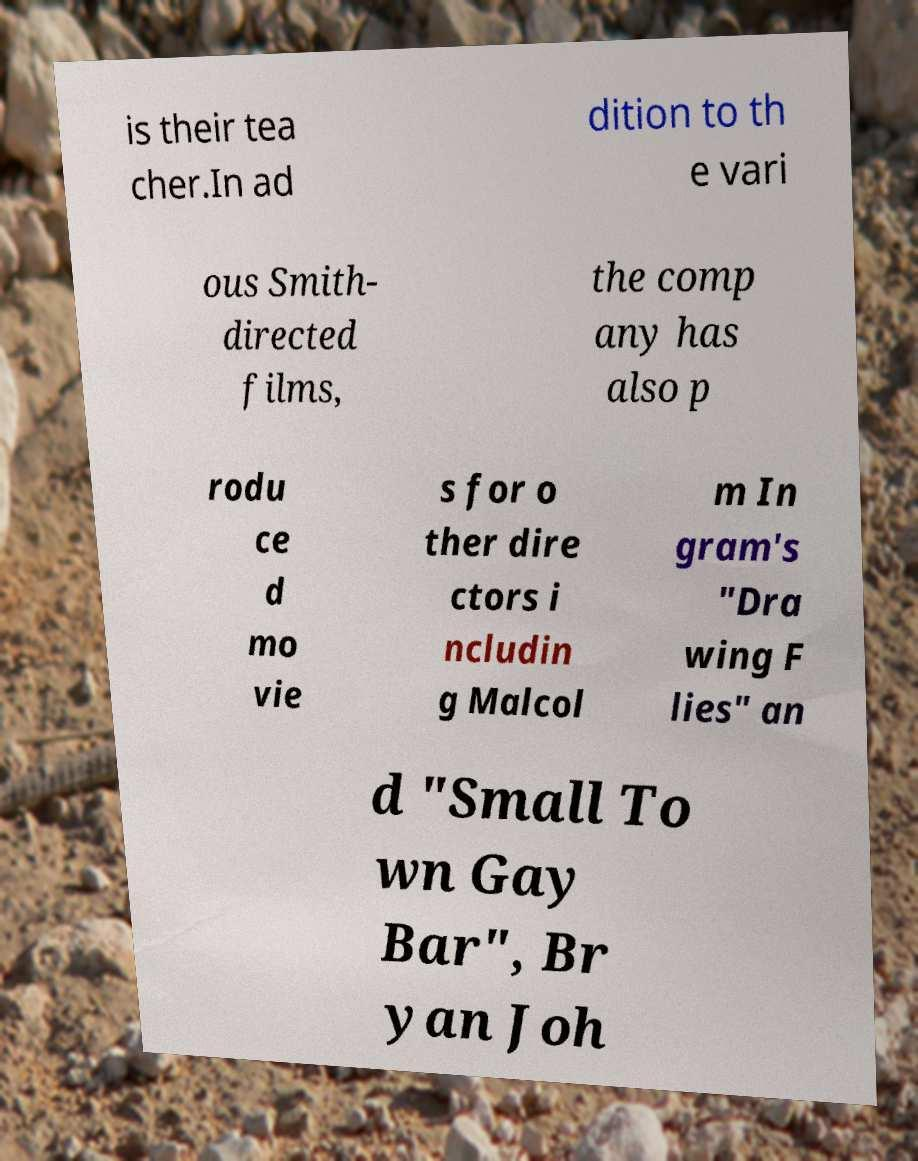Can you accurately transcribe the text from the provided image for me? is their tea cher.In ad dition to th e vari ous Smith- directed films, the comp any has also p rodu ce d mo vie s for o ther dire ctors i ncludin g Malcol m In gram's "Dra wing F lies" an d "Small To wn Gay Bar", Br yan Joh 